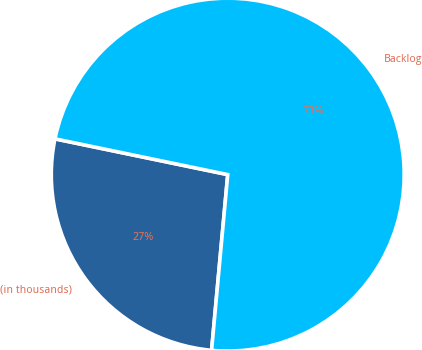Convert chart to OTSL. <chart><loc_0><loc_0><loc_500><loc_500><pie_chart><fcel>(in thousands)<fcel>Backlog<nl><fcel>26.79%<fcel>73.21%<nl></chart> 